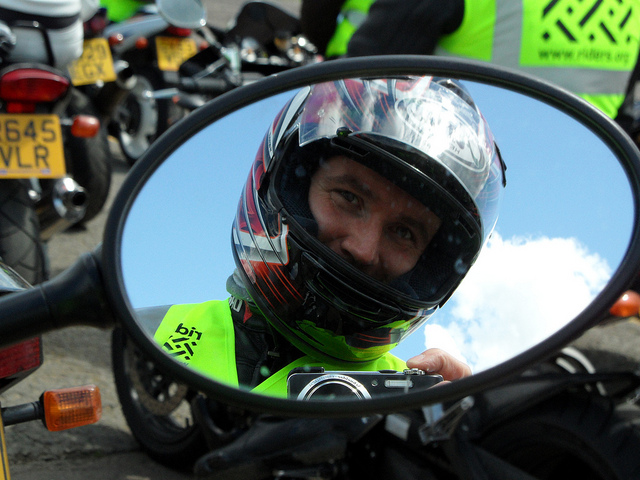Extract all visible text content from this image. rid 645 VLR 